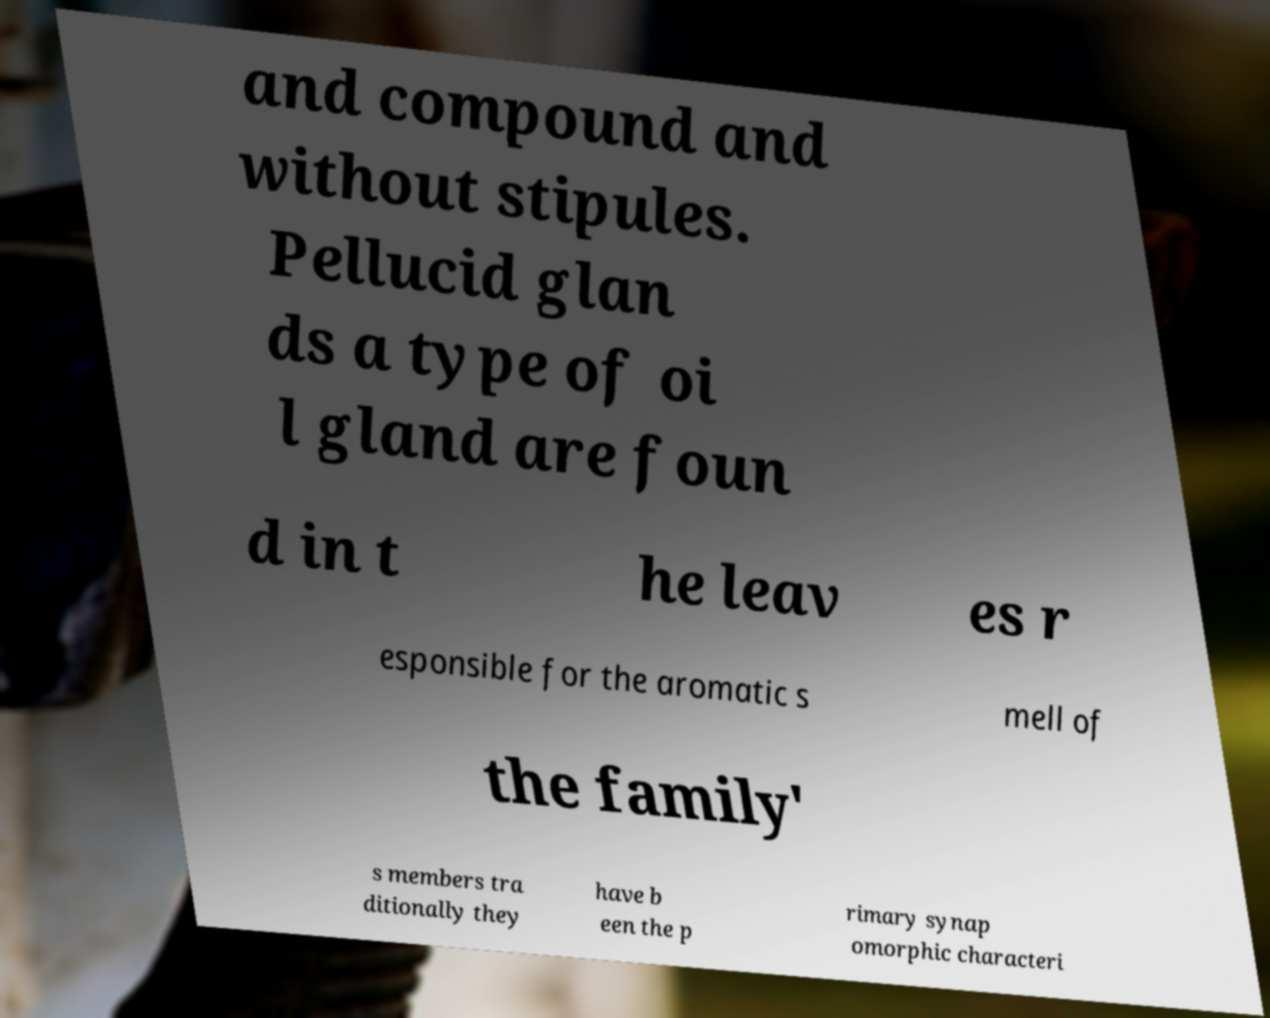Could you assist in decoding the text presented in this image and type it out clearly? and compound and without stipules. Pellucid glan ds a type of oi l gland are foun d in t he leav es r esponsible for the aromatic s mell of the family' s members tra ditionally they have b een the p rimary synap omorphic characteri 